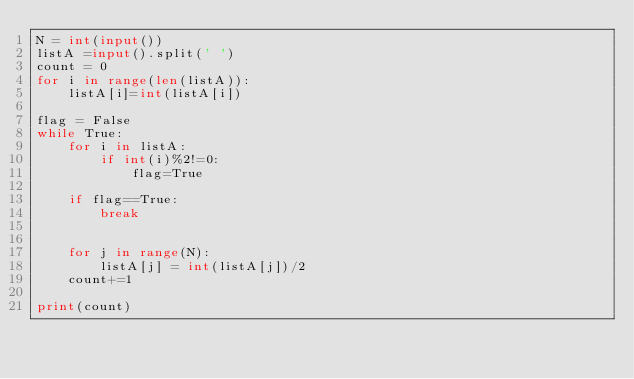Convert code to text. <code><loc_0><loc_0><loc_500><loc_500><_Python_>N = int(input())
listA =input().split(' ')
count = 0
for i in range(len(listA)):
    listA[i]=int(listA[i])

flag = False
while True:
    for i in listA:
        if int(i)%2!=0:
            flag=True

    if flag==True:
        break


    for j in range(N):
        listA[j] = int(listA[j])/2
    count+=1

print(count)


</code> 